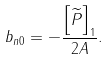Convert formula to latex. <formula><loc_0><loc_0><loc_500><loc_500>b _ { n 0 } = - \frac { \left [ \widetilde { P } \right ] _ { 1 } } { 2 A } .</formula> 